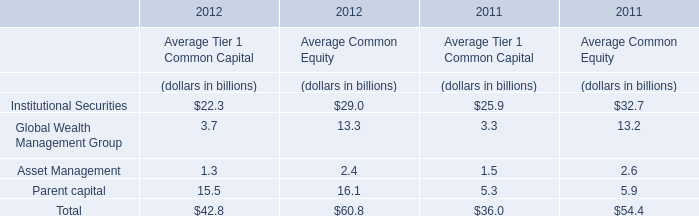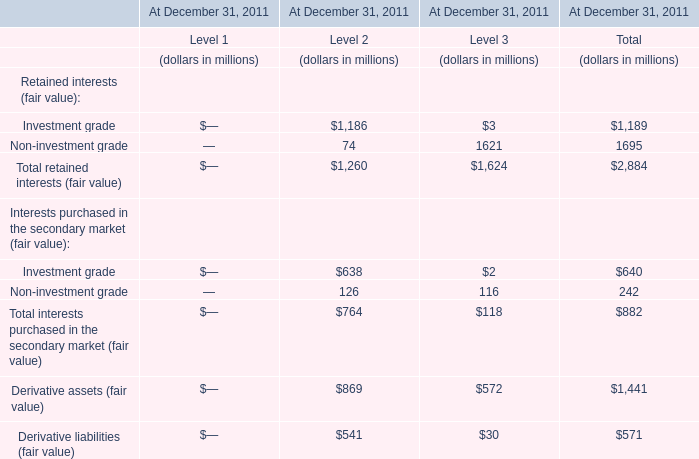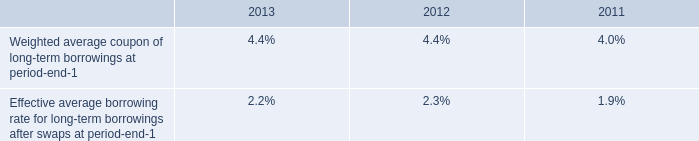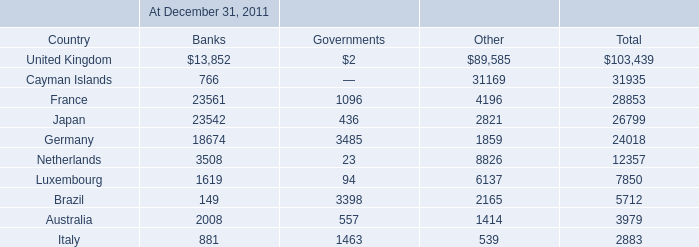What is the sum of the Derivative assets (fair value) for Level 2 in 2011? (in million) 
Answer: 869. 